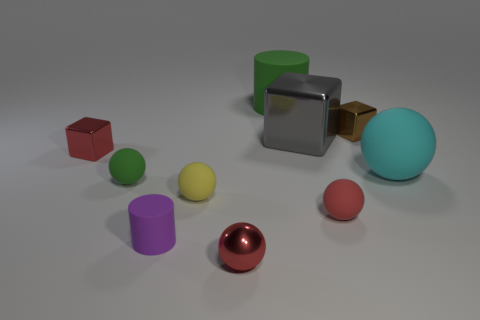There is a rubber cylinder behind the brown metallic block; is it the same color as the tiny rubber object behind the yellow rubber thing?
Keep it short and to the point. Yes. What is the color of the cube that is both behind the red block and left of the small brown metal thing?
Provide a succinct answer. Gray. There is a block in front of the gray metallic cube; is its size the same as the sphere that is left of the small cylinder?
Your answer should be compact. Yes. How many other things are the same size as the gray metal block?
Give a very brief answer. 2. There is a tiny metallic block that is on the left side of the purple rubber object; how many red things are in front of it?
Provide a short and direct response. 2. Is the number of tiny matte balls in front of the purple matte object less than the number of big metallic balls?
Make the answer very short. No. The small metallic thing right of the cylinder that is behind the tiny shiny cube on the right side of the big green rubber thing is what shape?
Ensure brevity in your answer.  Cube. Does the big shiny object have the same shape as the tiny brown thing?
Provide a succinct answer. Yes. How many other objects are there of the same shape as the small brown object?
Offer a terse response. 2. There is a metal sphere that is the same size as the brown thing; what color is it?
Ensure brevity in your answer.  Red. 